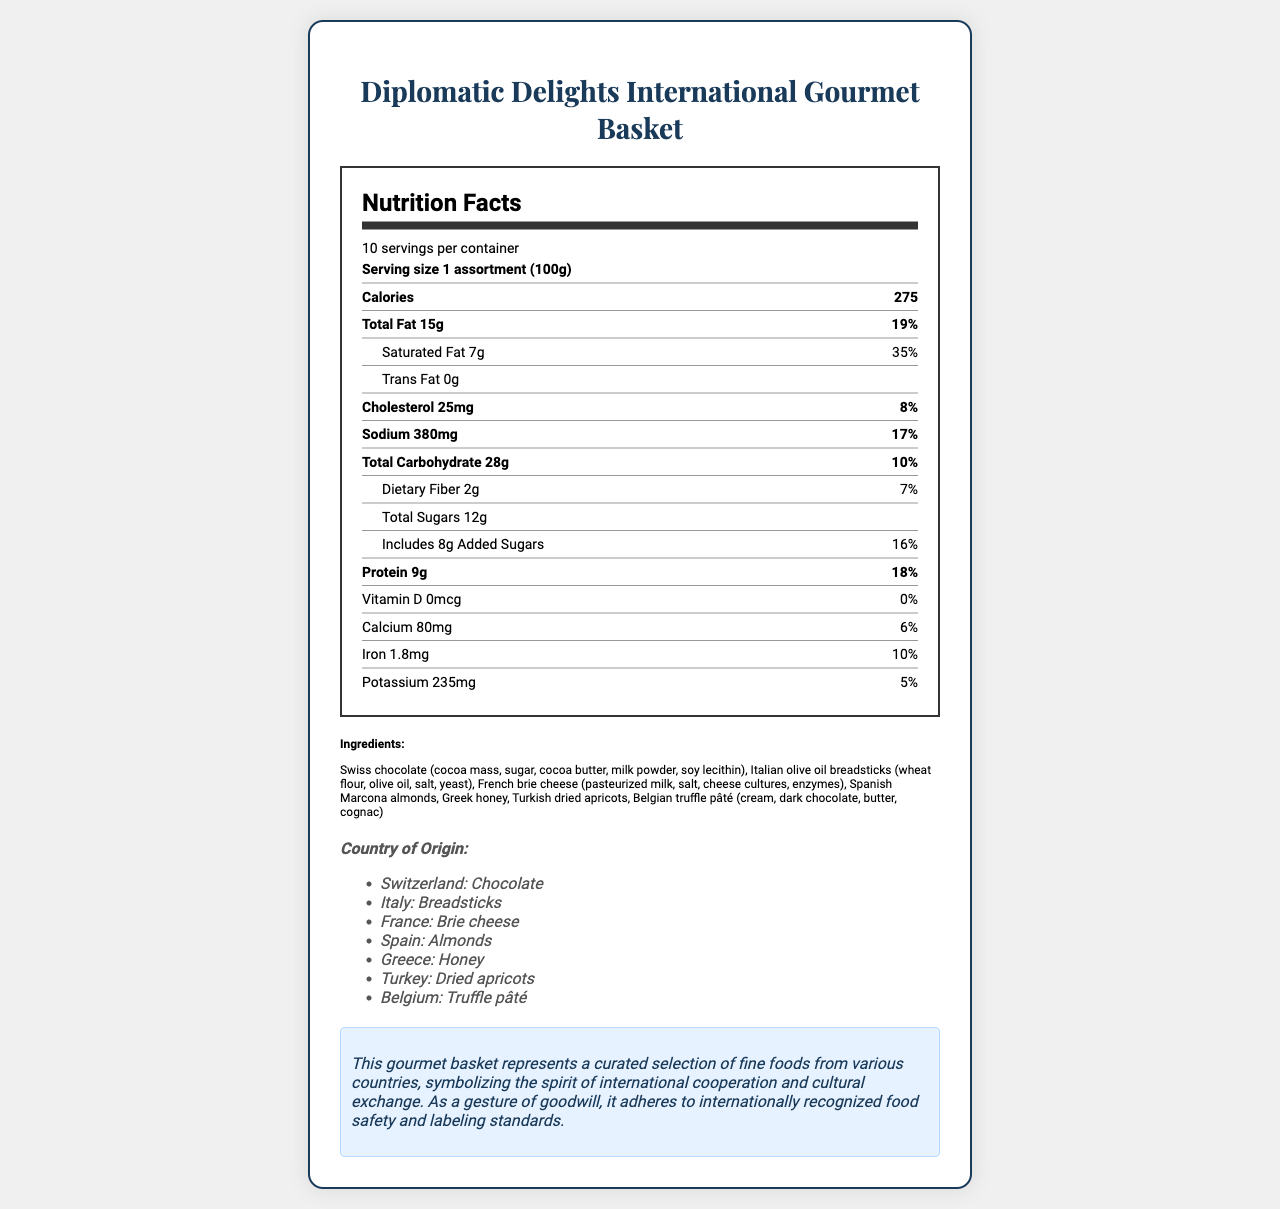what is the serving size? The serving size is stated at the top of the document under Nutrition Facts and is given as "Serving size 1 assortment (100g)".
Answer: 1 assortment (100g) how many servings are in the container? The document states "10 servings per container" right under the product name and serving size information.
Answer: 10 how much total fat is in one serving? The amount of total fat per serving is listed as 15 grams in the nutritional information section.
Answer: 15g what percentage of the daily value is provided by saturated fat? The document lists the daily value for saturated fat as 35% in the nutrition facts table, under the saturated fat row.
Answer: 35% which ingredients may cause allergies? The allergen information is listed near the bottom and includes Milk, Wheat, Soy, and Tree Nuts (Almonds, Hazelnuts).
Answer: Milk, Wheat, Soy, Tree Nuts (Almonds, Hazelnuts) where does the brie cheese come from? Under the country of origin section, it lists France as the source of the Brie cheese.
Answer: France which of the following is NOT an ingredient in the Diplomatic Delights International Gourmet Basket? A. Greek honey B. Spanish olives C. French brie cheese D. Turkish dried apricots Spanish olives are not listed in the ingredients, while Greek honey, French brie cheese, and Turkish dried apricots are included.
Answer: B what is the total carbohydrate amount per serving? The total carbohydrate content per serving is listed as 28 grams in the nutrition facts section.
Answer: 28g is there any vitamin D in this product? The document indicates that there is 0 micrograms of Vitamin D and a daily value of 0%.
Answer: No describe the document briefly. The document serves as a comprehensive guide to understanding the nutritional value and origin of ingredients in the gourmet basket, emphasizing both health and diplomatic themes.
Answer: The document provides detailed nutrition facts and ingredient information for the Diplomatic Delights International Gourmet Basket. It includes serving size, calories, macronutrient content, vitamins, minerals, allergen information, and the countries of origin for various ingredients. There is also a diplomatic note emphasizing international cooperation and food safety standards. what is the cholesterol content per serving? The cholesterol content per serving is listed as 25 milligrams in the nutrition facts section.
Answer: 25mg how many grams of added sugars are in each serving? The document states that there are 8 grams of added sugars per serving.
Answer: 8g calculate the total amount of calories in the entire container. A. 1650 B. 2750 C. 2000 D. 275 Since there are 10 servings per container and each serving has 275 calories, the total calories in the container are 275 * 10 = 2750.
Answer: A is there any trans fat in the product? The nutritional facts state that there are 0 grams of trans fat per serving.
Answer: No what is the source of the Marcona almonds in the basket? The country of origin section lists Spain as the source of the Marcona almonds.
Answer: Spain what is the potassium content in one serving? The potassium content per serving is listed as 235 milligrams in the nutrition facts section.
Answer: 235mg what is the amount of protein in the entire container? Since there are 10 servings per container and each serving has 9 grams of protein, the total protein content in the entire container is 9g * 10 = 90g.
Answer: 90g 